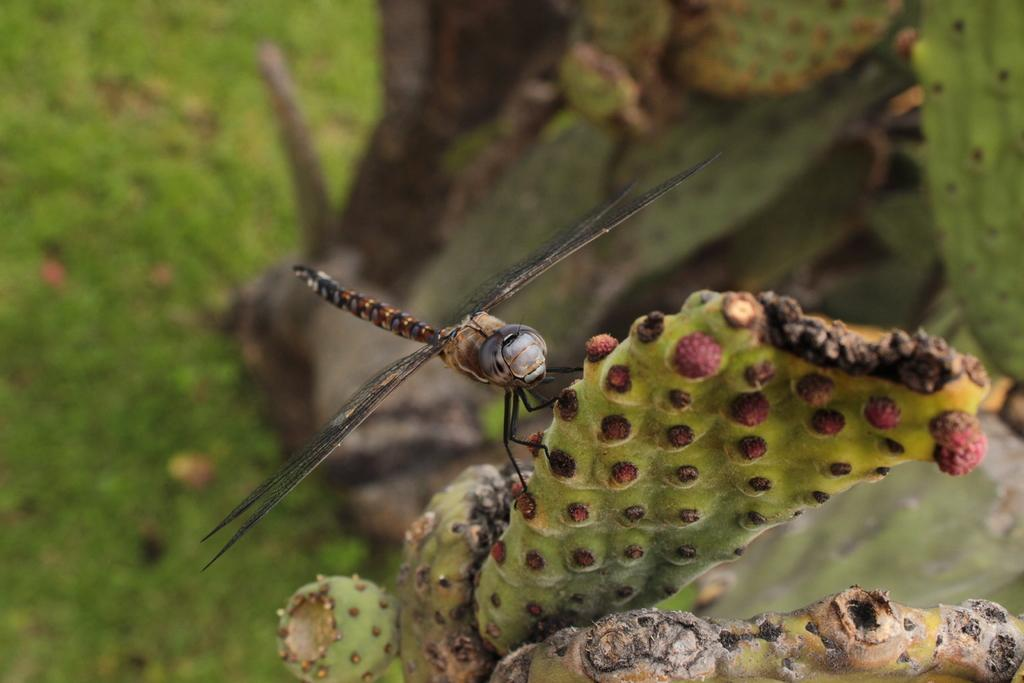What type of plant is in the image? There is a cactus plant in the image. What insect can be seen on the cactus plant? There is a dragonfly on the cactus plant. Can you describe the background of the image? The background of the image is green and blurred. Where is the oven located in the image? There is no oven present in the image. Is there a ring visible on the dragonfly's finger in the image? Dragonflies do not have fingers, and there is no ring visible on the dragonfly in the image. --- Facts: 1. There is a person holding a camera in the image. 2. The person is wearing a hat. 3. The background of the image is a cityscape. 4. There are buildings visible in the background. Absurd Topics: elephant, swimming pool, umbrella Conversation: What is the person in the image holding? The person in the image is holding a camera. Can you describe the person's attire in the image? The person is wearing a hat. What can be seen in the background of the image? The background of the image is a cityscape, and there are buildings visible in the background. Reasoning: Let's think step by step in order to produce the conversation. We start by identifying the main subject in the image, which is the person holding a camera. Then, we expand the conversation to include the person's hat, which is another important element in the image. Finally, we describe the background of the image, which adds context to the overall scene. Absurd Question/Answer: Where is the elephant located in the image? There is no elephant present in the image. Is there a swimming pool visible in the background of the image? There is no swimming pool visible in the background of the image; it features a cityscape with buildings. Can you tell me if the person in the image is holding an umbrella? The person in the image is holding a camera, not an umbrella. 